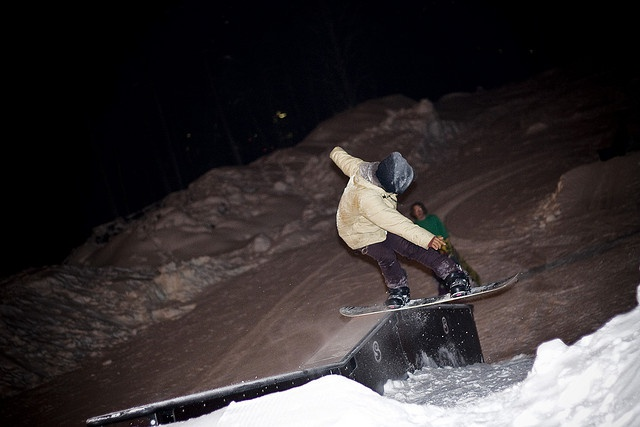Describe the objects in this image and their specific colors. I can see people in black, tan, darkgray, and gray tones, snowboard in black, gray, darkgray, and lightgray tones, and people in black, maroon, and darkgreen tones in this image. 